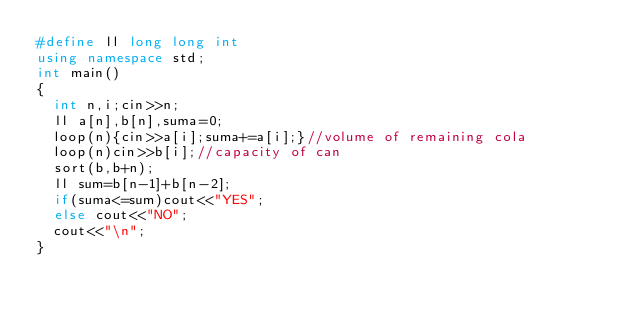Convert code to text. <code><loc_0><loc_0><loc_500><loc_500><_C++_>#define ll long long int
using namespace std;
int main()
{
  int n,i;cin>>n;
  ll a[n],b[n],suma=0;
  loop(n){cin>>a[i];suma+=a[i];}//volume of remaining cola
  loop(n)cin>>b[i];//capacity of can
  sort(b,b+n);
  ll sum=b[n-1]+b[n-2];
  if(suma<=sum)cout<<"YES";
  else cout<<"NO";
  cout<<"\n";
}</code> 